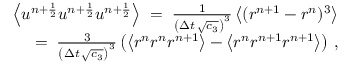Convert formula to latex. <formula><loc_0><loc_0><loc_500><loc_500>\begin{array} { r l r } & { \left \langle u ^ { n + \frac { 1 } { 2 } } u ^ { n + \frac { 1 } { 2 } } u ^ { n + \frac { 1 } { 2 } } \right \rangle \, = \, \frac { 1 } { \left ( \Delta { t } \, \sqrt { c _ { 3 } } \right ) ^ { 3 } } \left \langle ( r ^ { n + 1 } - r ^ { n } ) ^ { 3 } \right \rangle } \\ & { = \, \frac { 3 } { \left ( \Delta { t } \, \sqrt { c _ { 3 } } \right ) ^ { 3 } } \left ( \left \langle r ^ { n } r ^ { n } r ^ { n + 1 } \right \rangle - \left \langle r ^ { n } r ^ { n + 1 } r ^ { n + 1 } \right \rangle \right ) \, , } \end{array}</formula> 